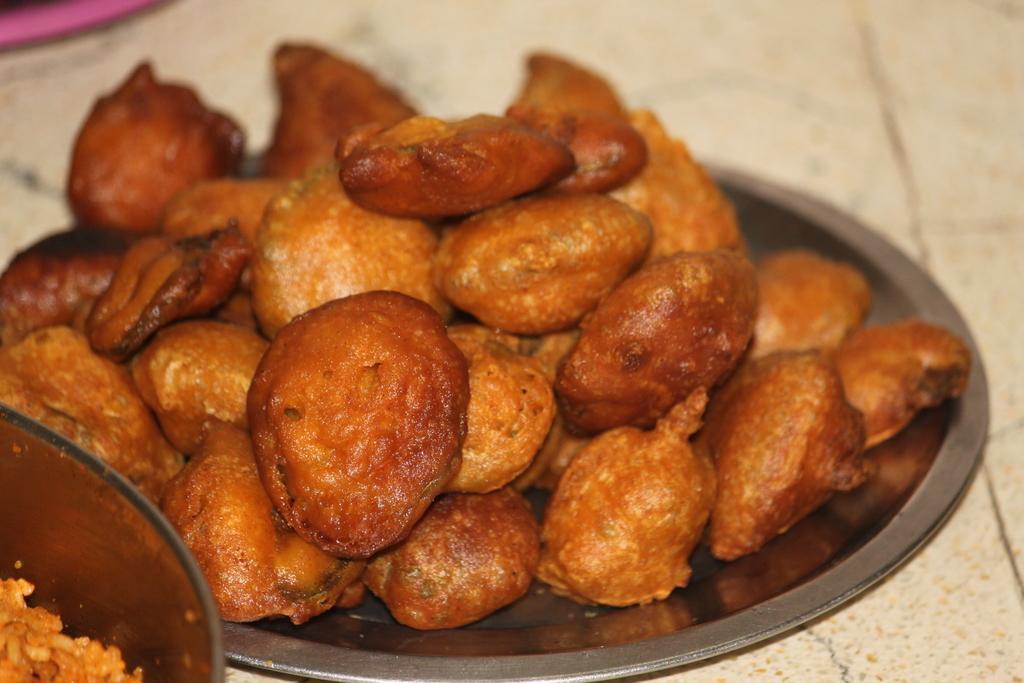Could you give a brief overview of what you see in this image? In this picture we can see food in the plate. 